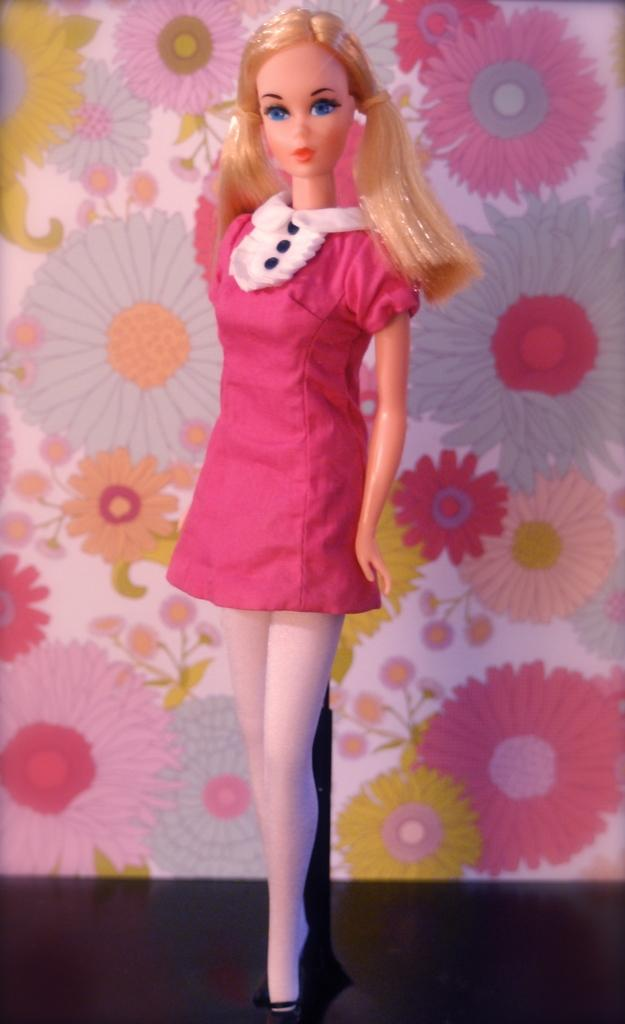What is the main object in the image? There is a toy in the image. What is the toy wearing? The toy is wearing a red dress. How does the toy look in the image? The toy appears to be stunning. What can be seen in the background of the image? There is a wall in the background of the image. Are there any pets visible in the image? There are no pets present in the image; it features a toy wearing a red dress. Can you see any flames in the image? There are no flames present in the image. 